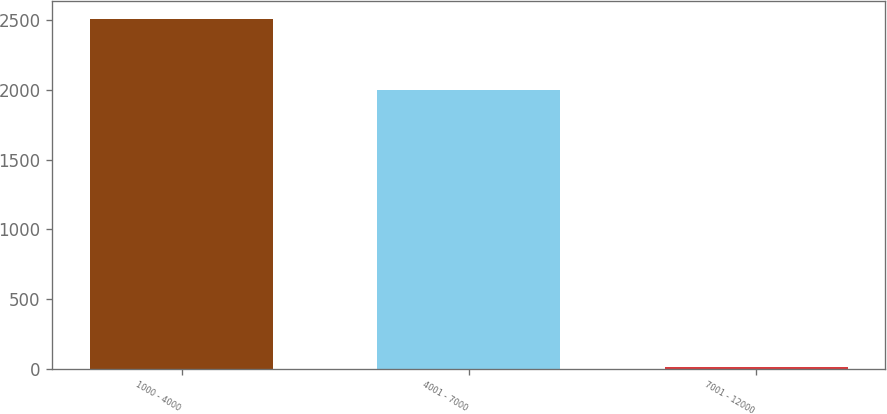Convert chart to OTSL. <chart><loc_0><loc_0><loc_500><loc_500><bar_chart><fcel>1000 - 4000<fcel>4001 - 7000<fcel>7001 - 12000<nl><fcel>2512<fcel>1996<fcel>14<nl></chart> 